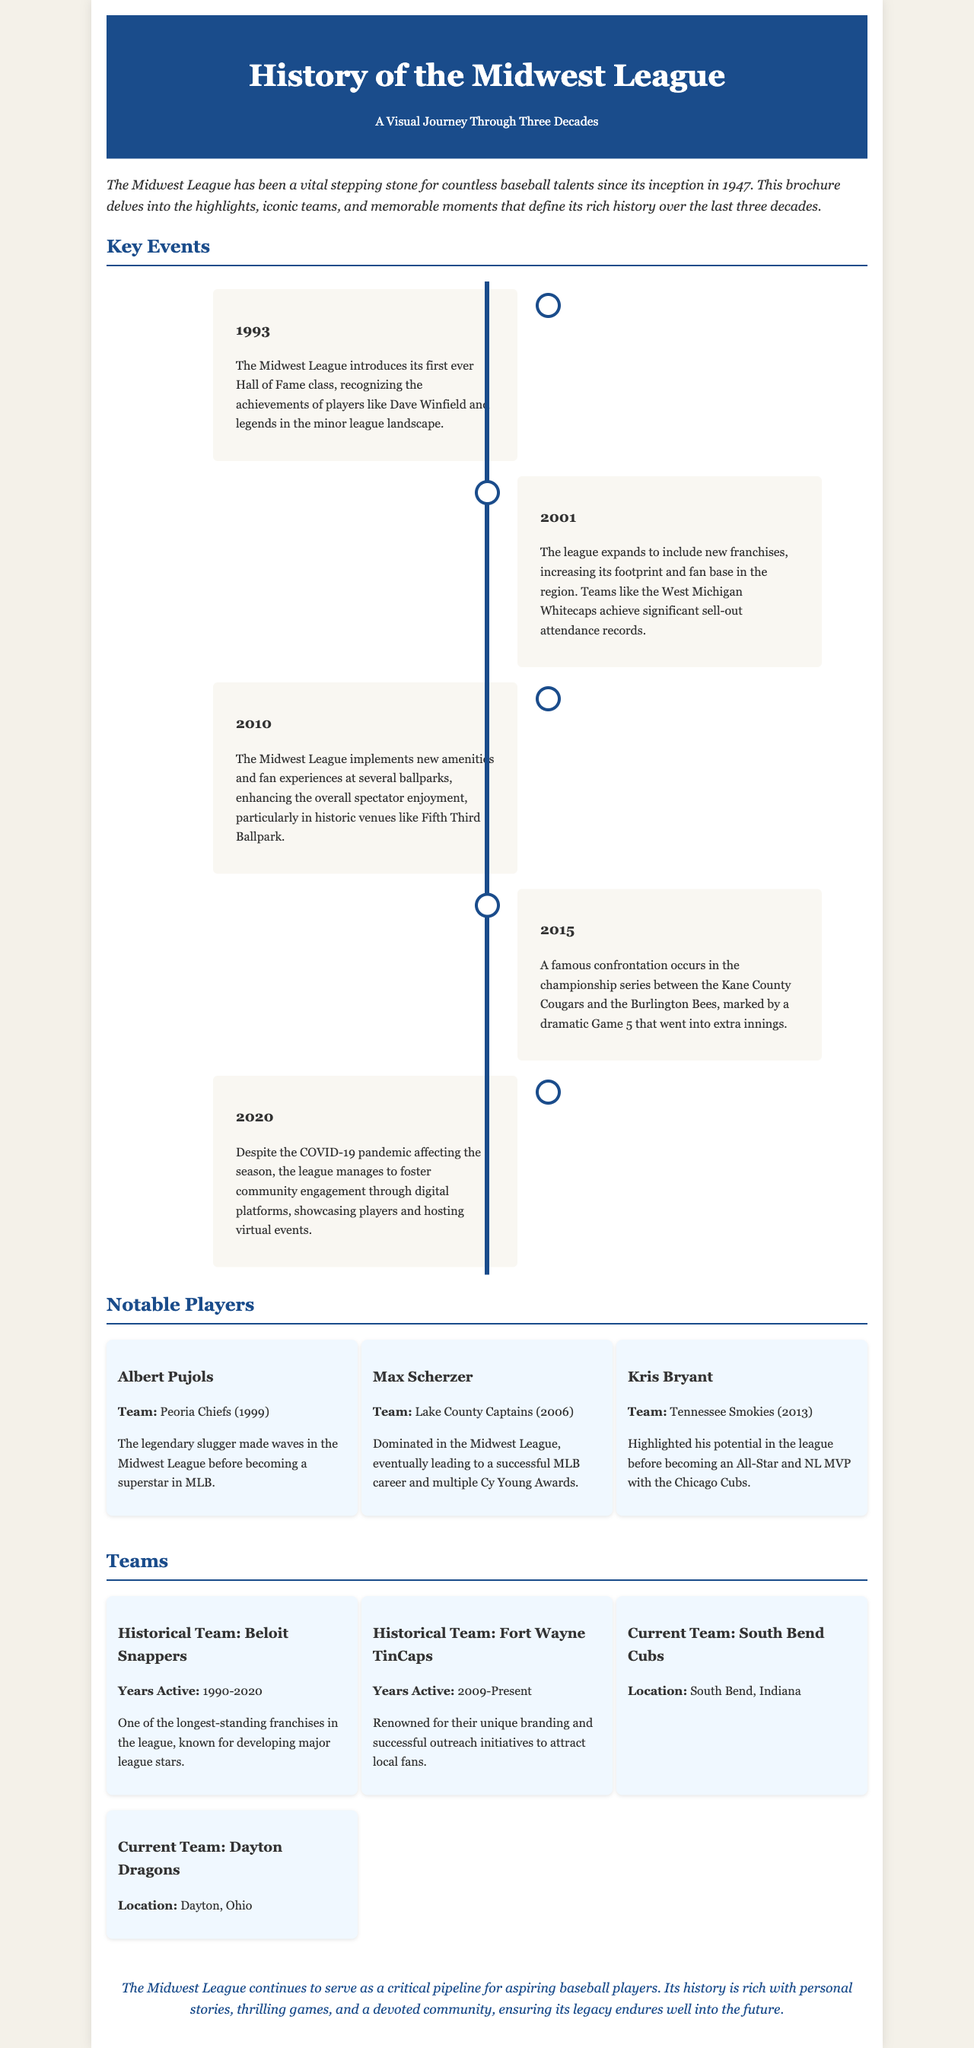What year was the first Hall of Fame class introduced? The document states that the first Hall of Fame class was introduced in 1993.
Answer: 1993 Who was a notable player from the Peoria Chiefs in 1999? The document mentions Albert Pujols as a notable player from the Peoria Chiefs in 1999.
Answer: Albert Pujols What significant event occurred in 2015? In 2015, a famous confrontation took place in the championship series between the Kane County Cougars and the Burlington Bees.
Answer: Championship series Which team is noted for its unique branding? The Fort Wayne TinCaps are recognized for their unique branding based on the information provided.
Answer: Fort Wayne TinCaps What was implemented in 2010 to enhance spectator enjoyment? The document states that new amenities and fan experiences were implemented at several ballparks in 2010.
Answer: New amenities How long did the Beloit Snappers remain active? The Beloit Snappers were active from 1990 to 2020, which makes it 30 years.
Answer: 30 years What percentage of events were held in the last decade? The document outlines key events and notable players but does not provide a percentage of events held in the last decade, focusing instead on specific years.
Answer: Not specified In what year did the Midwest League manage to foster community engagement despite the pandemic? The document states that community engagement was fostered in 2020 despite the COVID-19 pandemic.
Answer: 2020 Which player highlighted his potential in 2013? Kris Bryant is mentioned as the player who highlighted his potential in the Midwest League in 2013.
Answer: Kris Bryant 